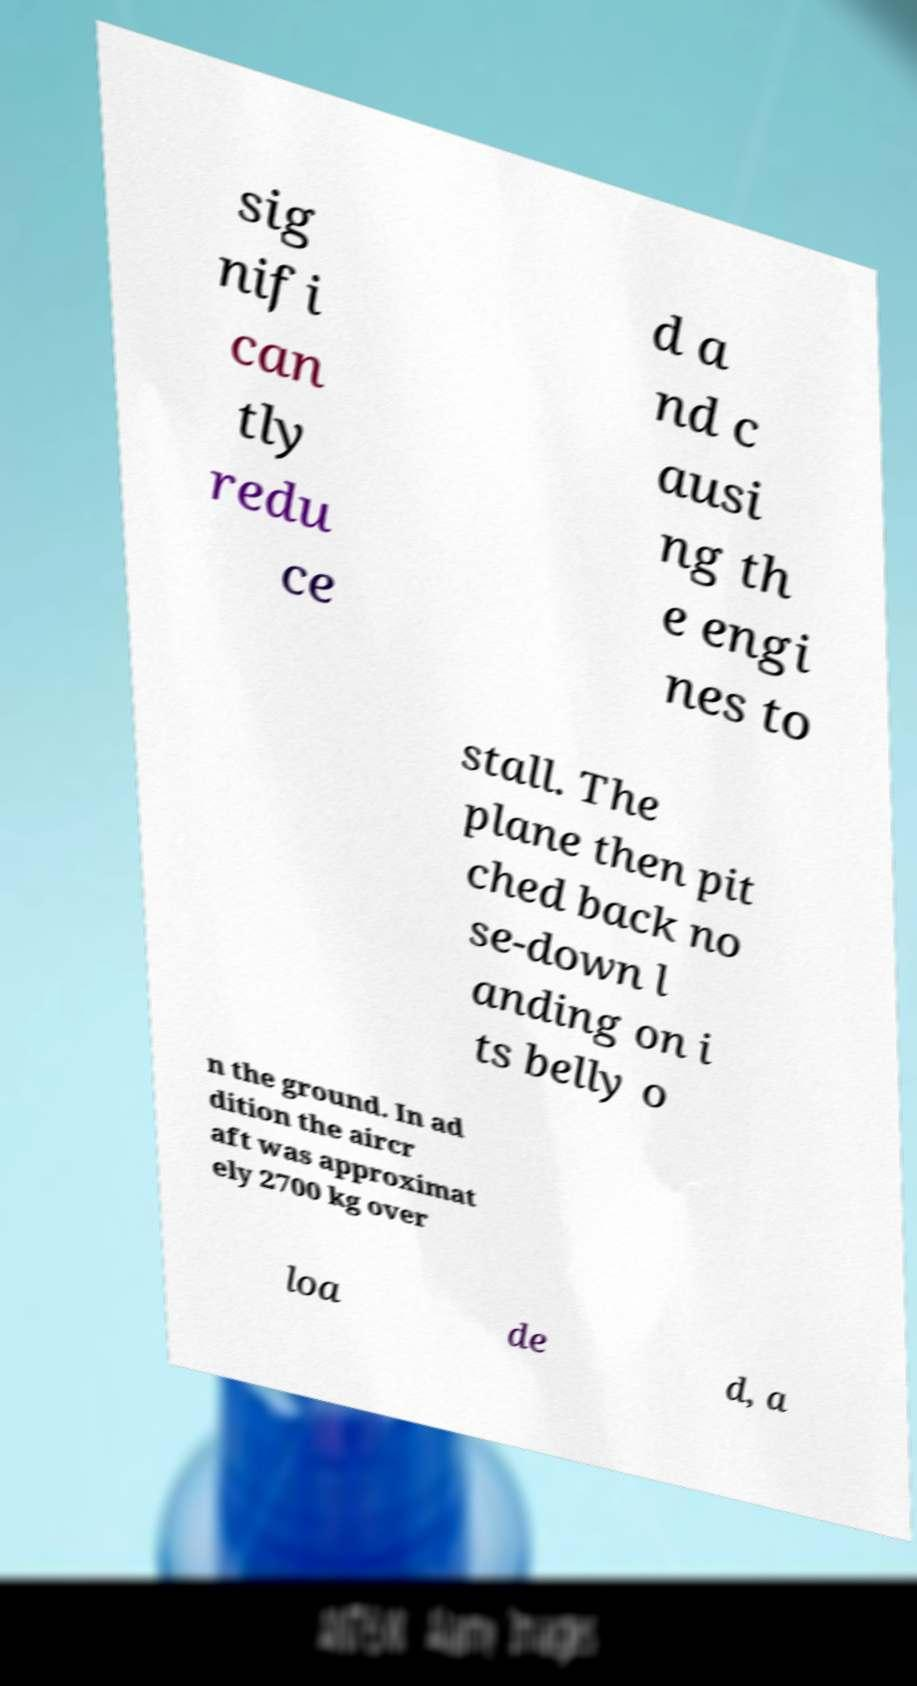What messages or text are displayed in this image? I need them in a readable, typed format. sig nifi can tly redu ce d a nd c ausi ng th e engi nes to stall. The plane then pit ched back no se-down l anding on i ts belly o n the ground. In ad dition the aircr aft was approximat ely 2700 kg over loa de d, a 